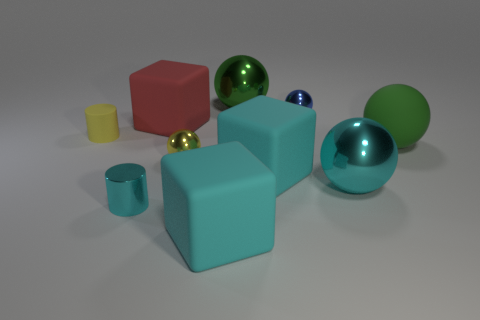Subtract 1 spheres. How many spheres are left? 4 Subtract all yellow spheres. How many spheres are left? 4 Subtract all small blue metallic spheres. How many spheres are left? 4 Subtract all red balls. Subtract all cyan blocks. How many balls are left? 5 Subtract all blocks. How many objects are left? 7 Add 2 big green objects. How many big green objects exist? 4 Subtract 1 green spheres. How many objects are left? 9 Subtract all blue metal things. Subtract all cyan objects. How many objects are left? 5 Add 6 big spheres. How many big spheres are left? 9 